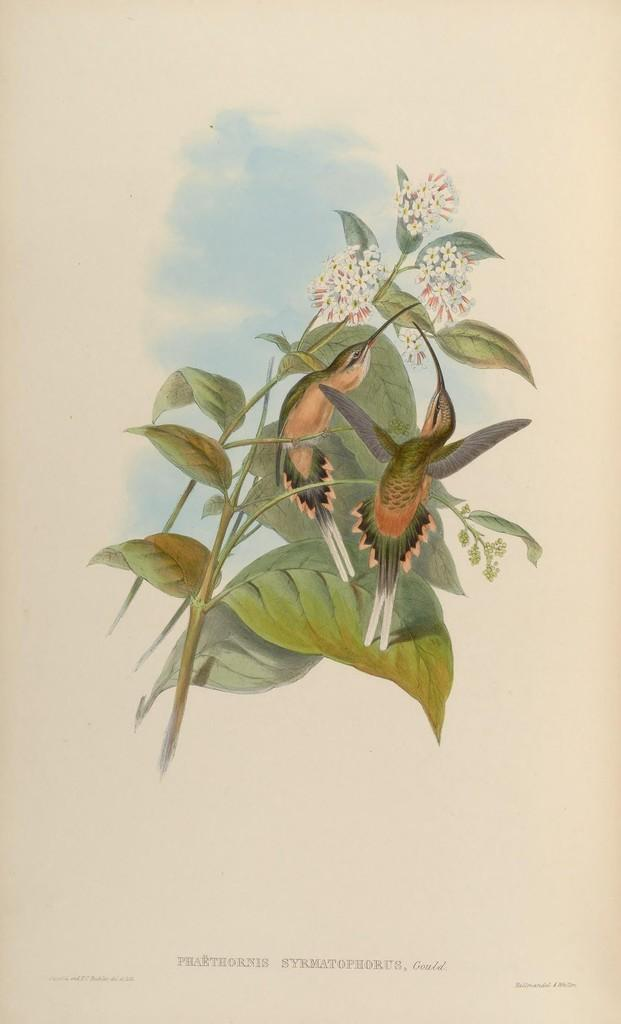What is depicted in the painting in the image? The painting contains a depiction of birds. What other elements are included in the painting? The painting includes stems with leaves and flowers. Is there any text present in the image? Yes, there is text present on the image. What type of channel can be seen running through the painting? There is no channel present in the painting; it features birds, stems with leaves and flowers, and text. 